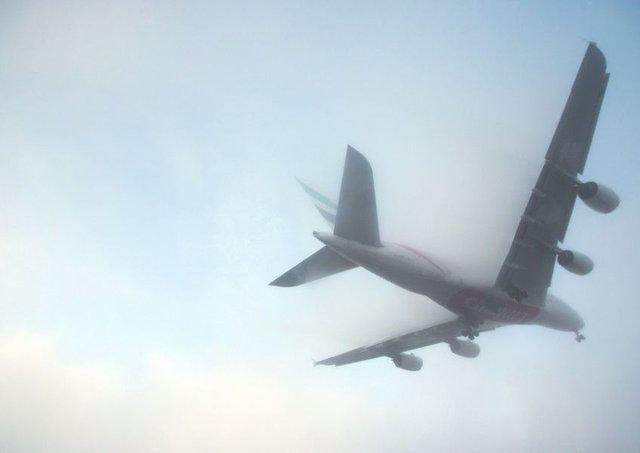Is there an aeroplane in the image? Yes, the image clearly shows an aeroplane captured in mid-flight. The plane is seen from below, with its underbelly and landing gear visible against a misty sky, suggesting it might be flying through a layer of clouds or fog. This adds a soft, almost ethereal quality to the image, emphasizing the airplane's graceful traversal through a vast, unclear sky. 